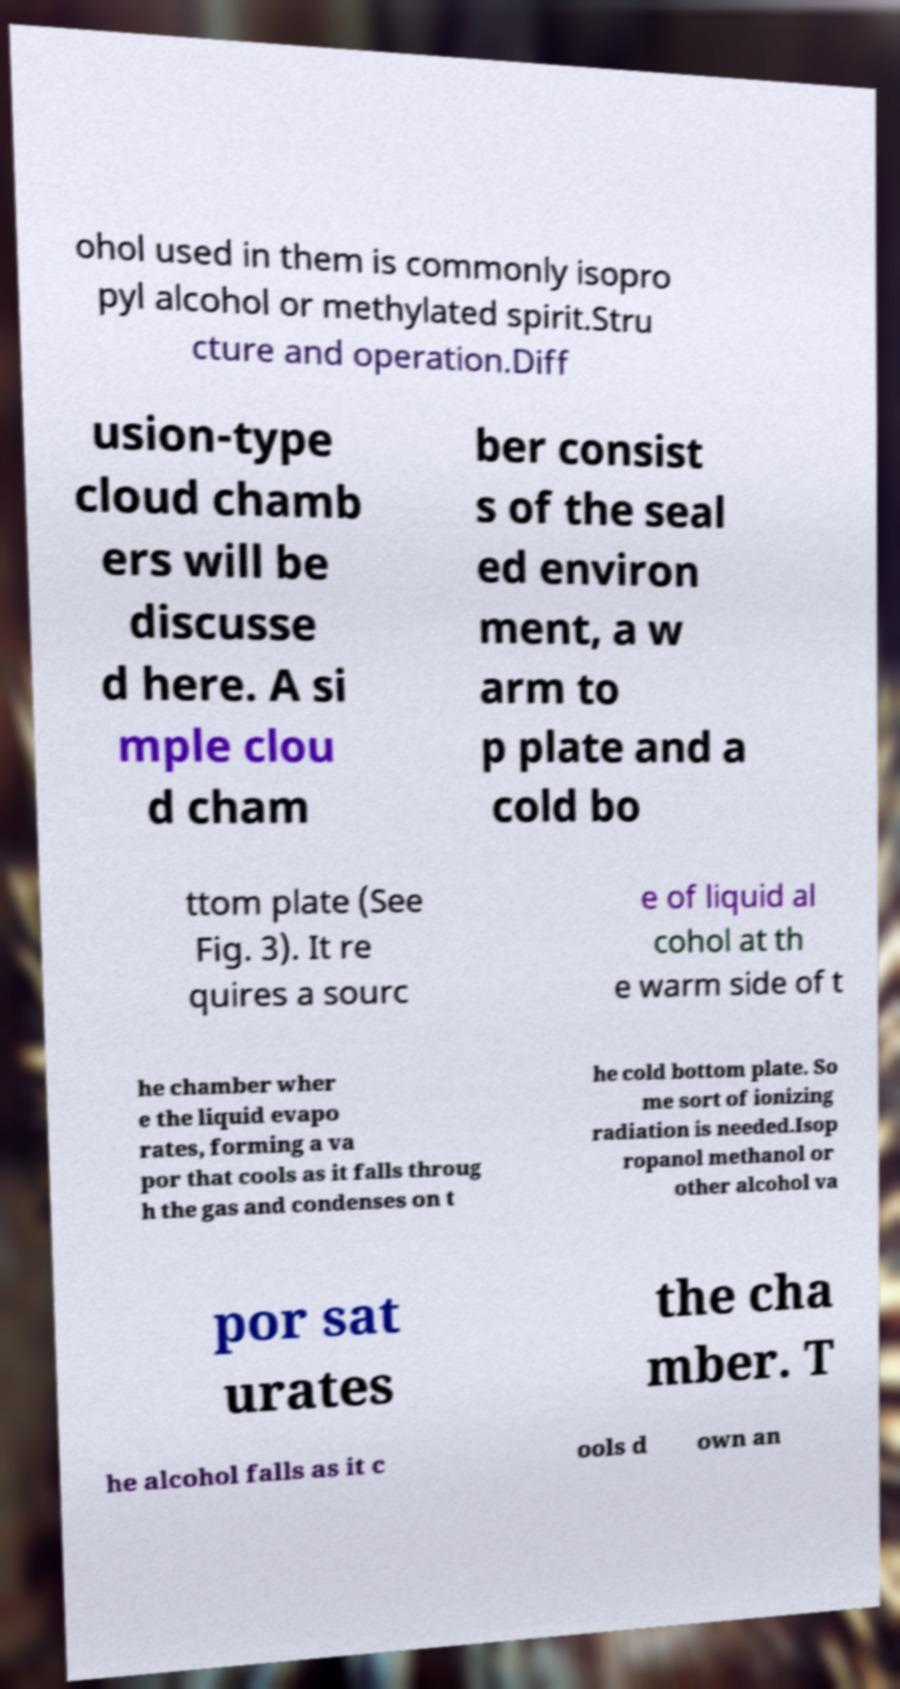Please identify and transcribe the text found in this image. ohol used in them is commonly isopro pyl alcohol or methylated spirit.Stru cture and operation.Diff usion-type cloud chamb ers will be discusse d here. A si mple clou d cham ber consist s of the seal ed environ ment, a w arm to p plate and a cold bo ttom plate (See Fig. 3). It re quires a sourc e of liquid al cohol at th e warm side of t he chamber wher e the liquid evapo rates, forming a va por that cools as it falls throug h the gas and condenses on t he cold bottom plate. So me sort of ionizing radiation is needed.Isop ropanol methanol or other alcohol va por sat urates the cha mber. T he alcohol falls as it c ools d own an 